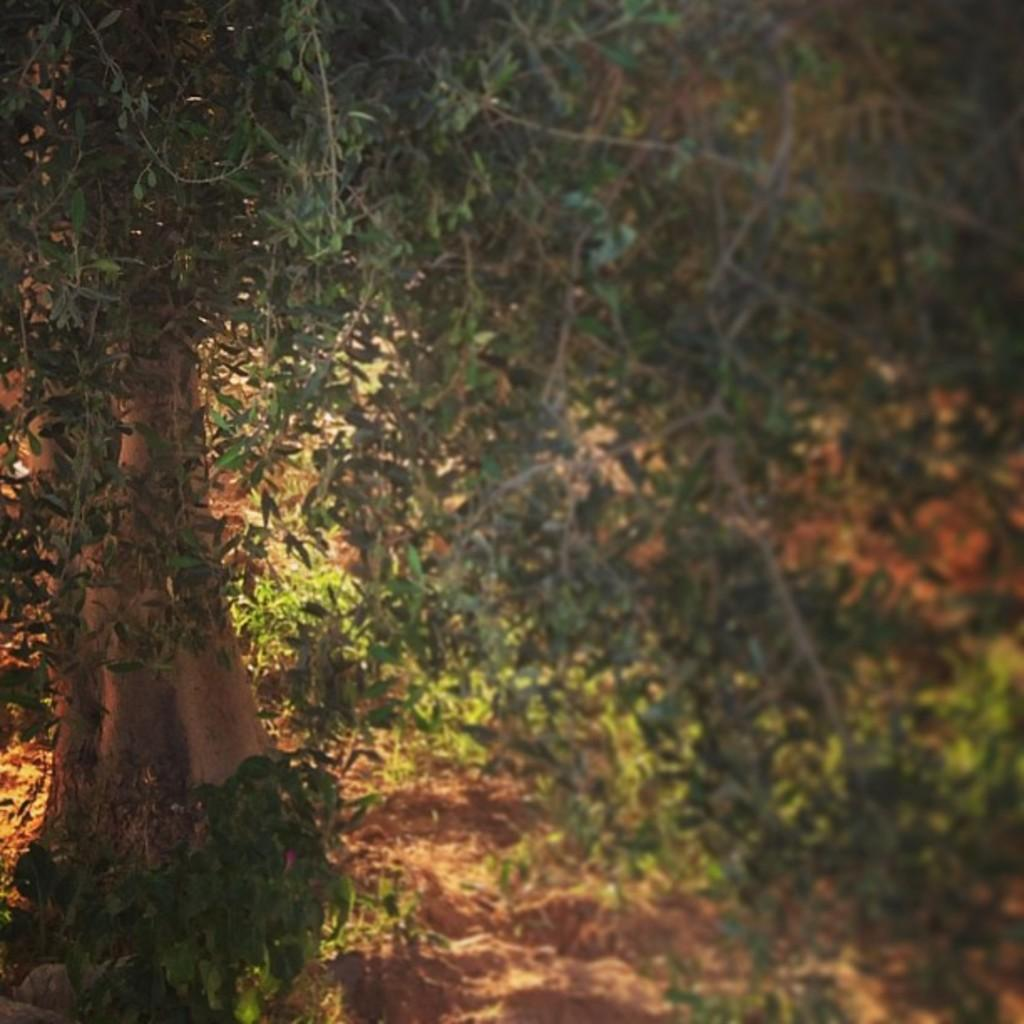What type of vegetation can be seen in the image? There are trees and plants on the ground in the image. Can you describe the plants on the ground? The plants on the ground are not specified in detail, but they are present in the image. What type of jewel is hanging from the tree in the image? There is no jewel hanging from the tree in the image; it only features trees and plants. Is there a girl playing with the plants in the image? There is no girl present in the image; it only features trees and plants. 